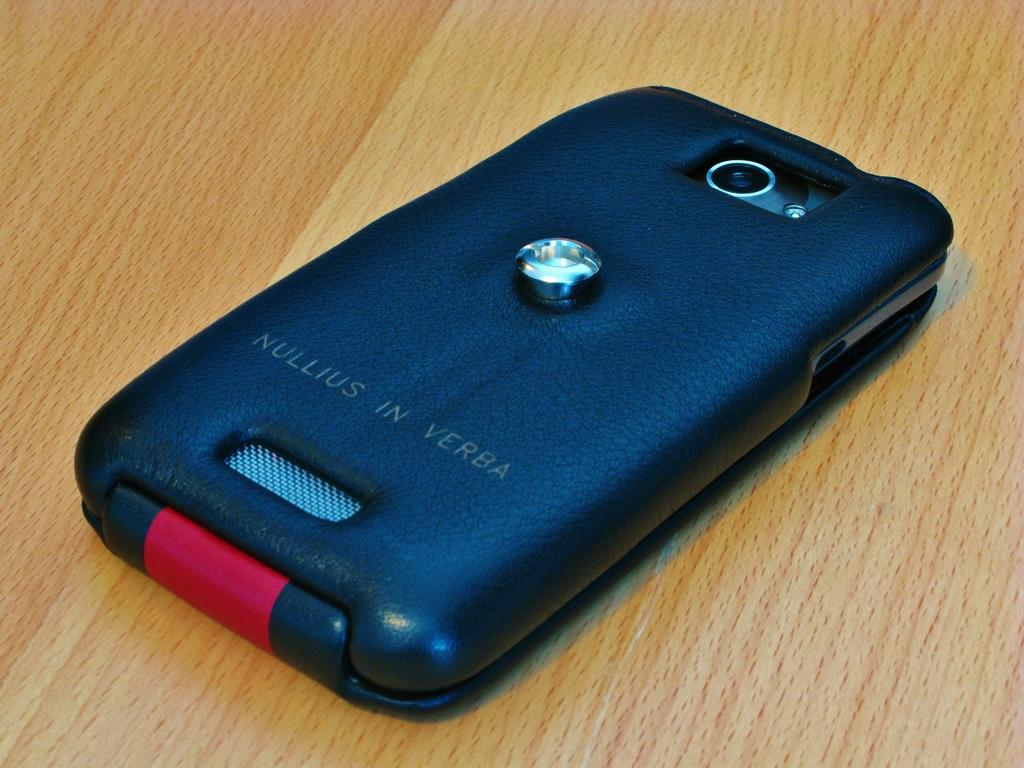<image>
Create a compact narrative representing the image presented. Nullius in Verba case on a phone on the table. 